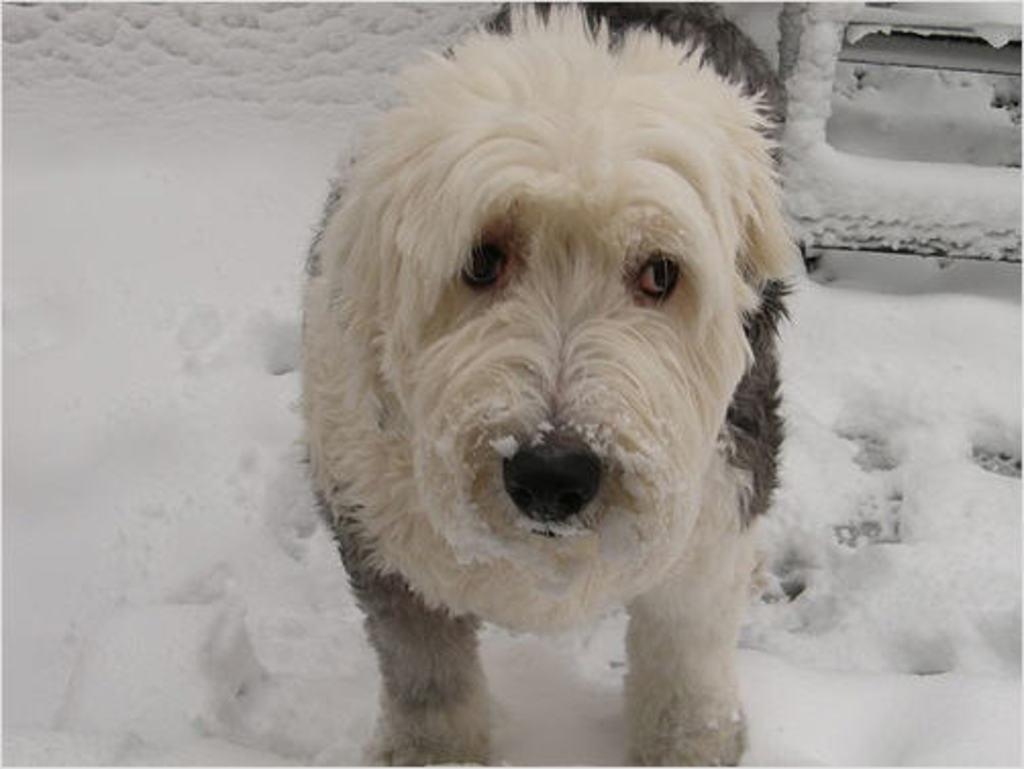What is the condition of the ground in the image? There is snow on the ground in the image. What color is the snow? The snow is white. What can be seen in the middle of the image? There is an animal standing in the middle of the image. What is placed on the right side of the image? There is an object placed on the right side of the image. What type of bean is being cooked by the uncle in the image? There is no uncle or bean present in the image. How does the boot help the animal in the image? There is no boot or indication of the animal needing assistance in the image. 